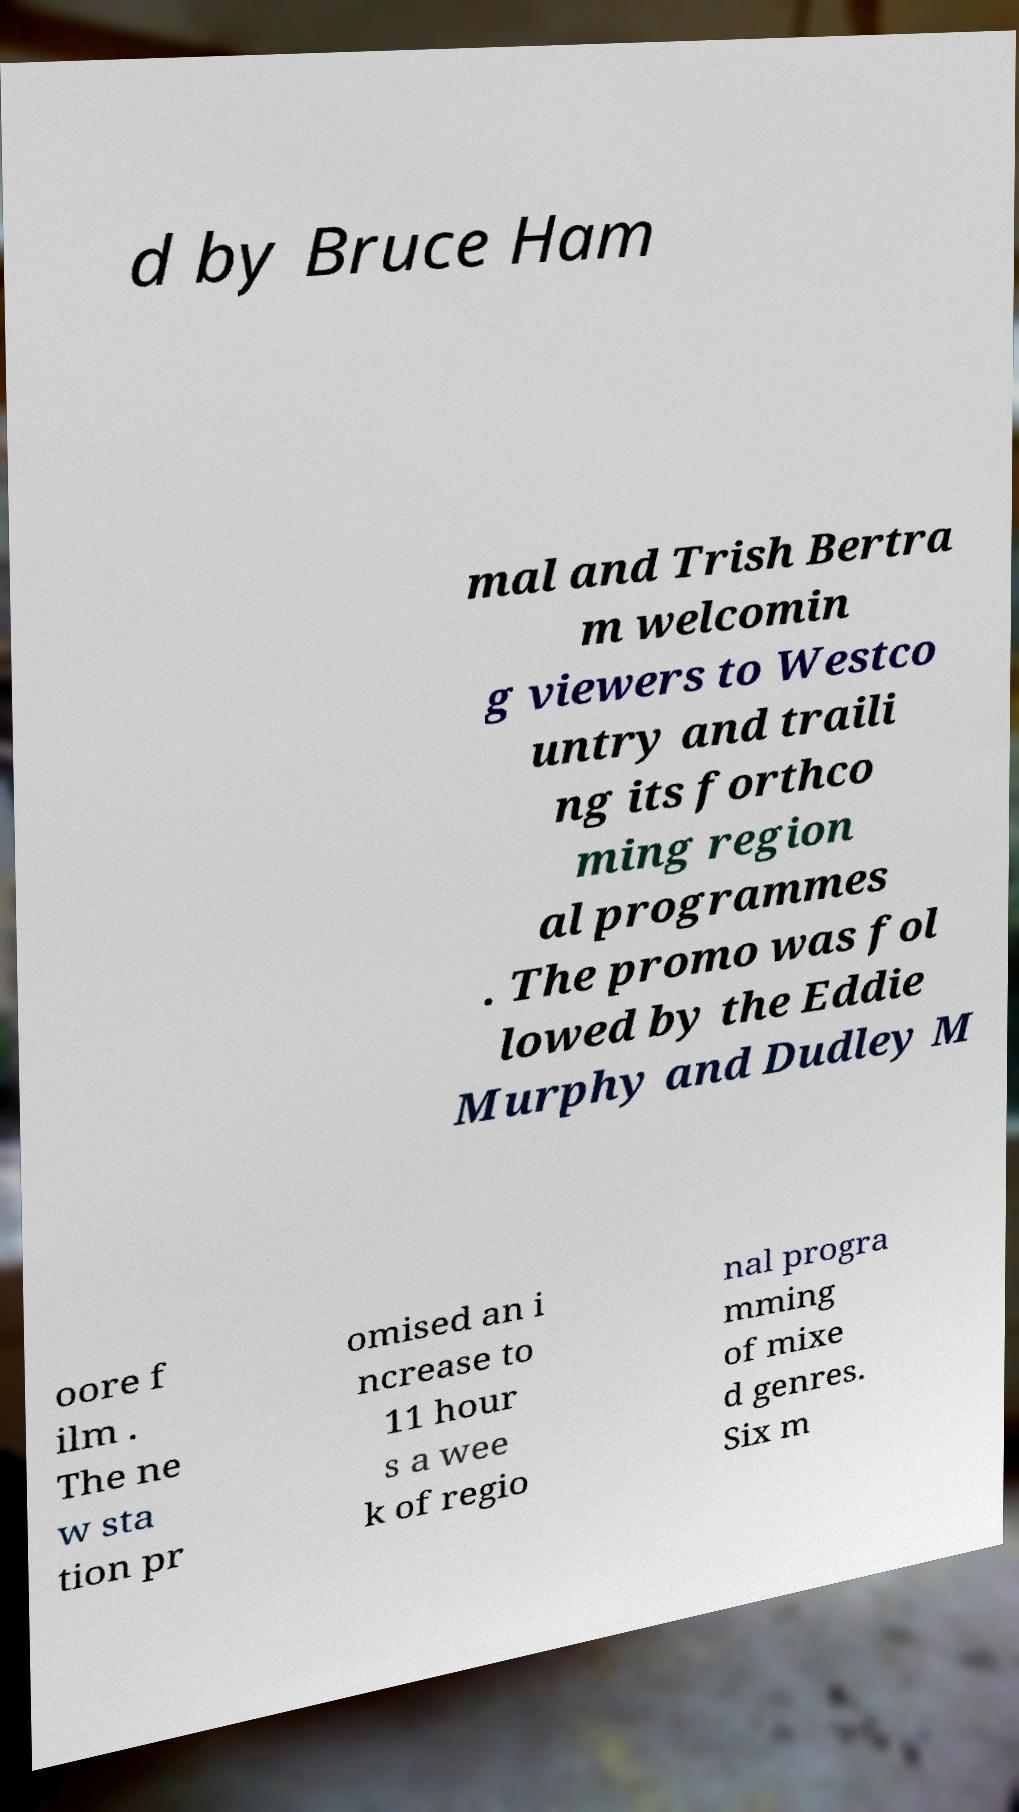Could you assist in decoding the text presented in this image and type it out clearly? d by Bruce Ham mal and Trish Bertra m welcomin g viewers to Westco untry and traili ng its forthco ming region al programmes . The promo was fol lowed by the Eddie Murphy and Dudley M oore f ilm . The ne w sta tion pr omised an i ncrease to 11 hour s a wee k of regio nal progra mming of mixe d genres. Six m 